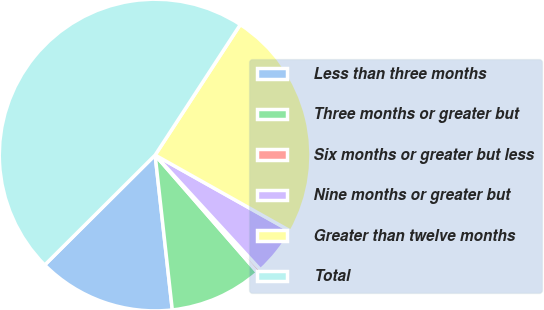<chart> <loc_0><loc_0><loc_500><loc_500><pie_chart><fcel>Less than three months<fcel>Three months or greater but<fcel>Six months or greater but less<fcel>Nine months or greater but<fcel>Greater than twelve months<fcel>Total<nl><fcel>14.29%<fcel>9.66%<fcel>0.41%<fcel>5.03%<fcel>23.94%<fcel>46.67%<nl></chart> 